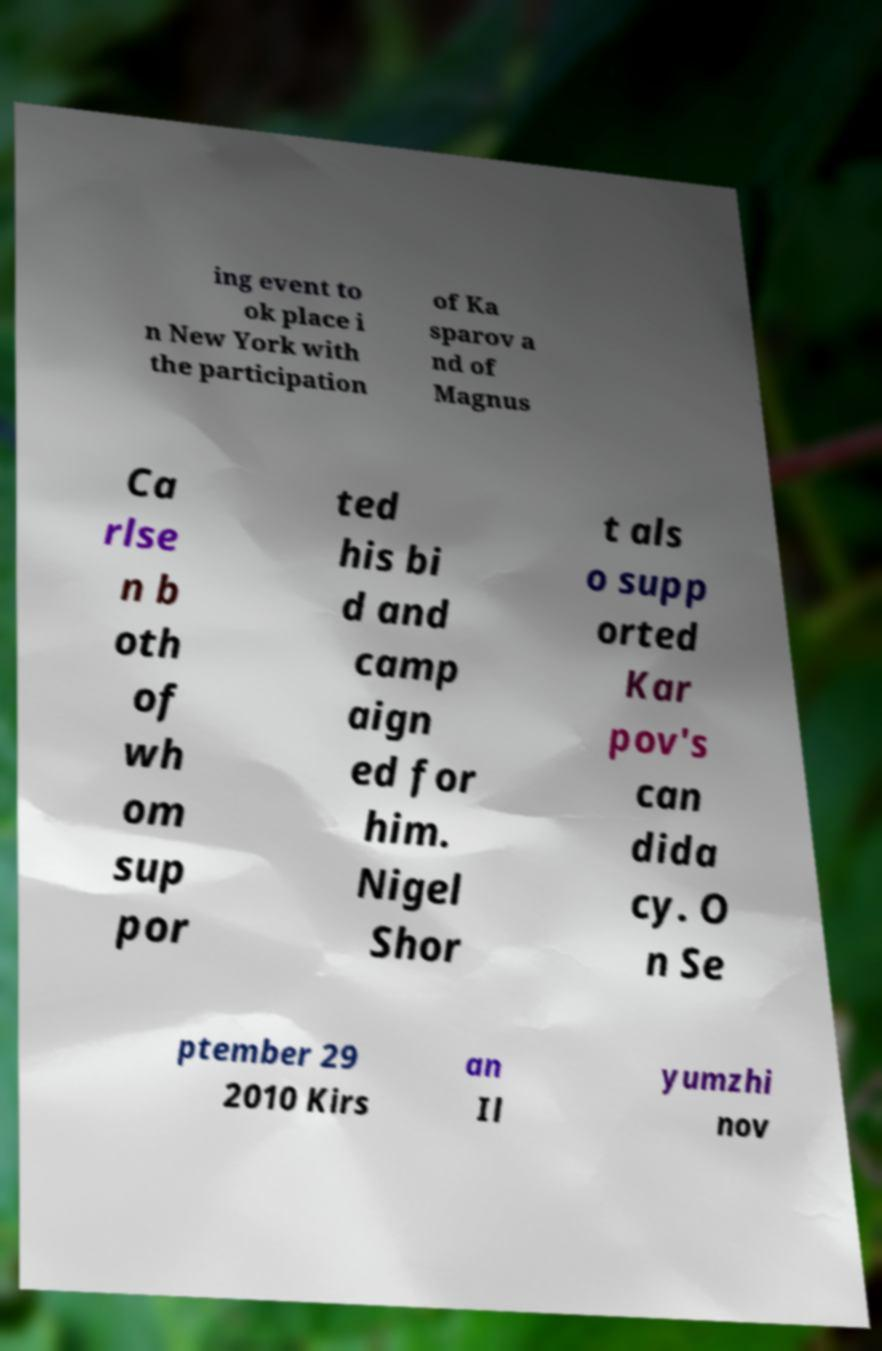I need the written content from this picture converted into text. Can you do that? ing event to ok place i n New York with the participation of Ka sparov a nd of Magnus Ca rlse n b oth of wh om sup por ted his bi d and camp aign ed for him. Nigel Shor t als o supp orted Kar pov's can dida cy. O n Se ptember 29 2010 Kirs an Il yumzhi nov 